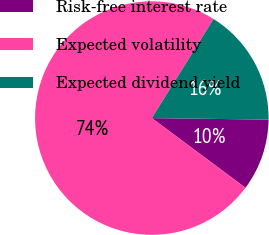Convert chart to OTSL. <chart><loc_0><loc_0><loc_500><loc_500><pie_chart><fcel>Risk-free interest rate<fcel>Expected volatility<fcel>Expected dividend yield<nl><fcel>9.97%<fcel>73.69%<fcel>16.34%<nl></chart> 